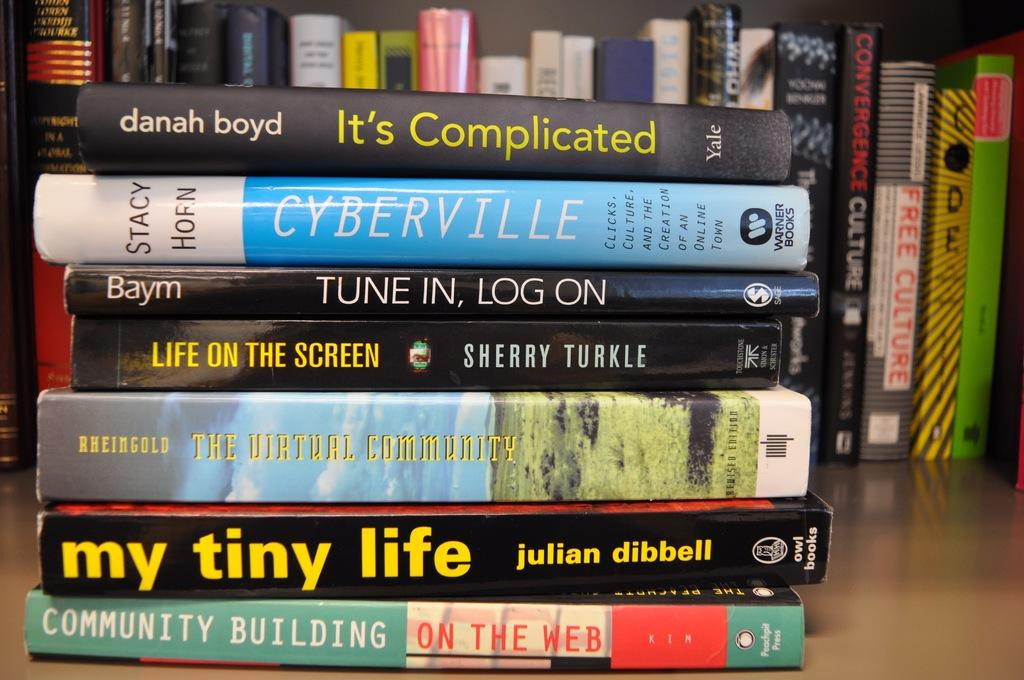<image>
Summarize the visual content of the image. Different books stacked on top of each other, top book says Danah Boyd Its Complicated Yale. 